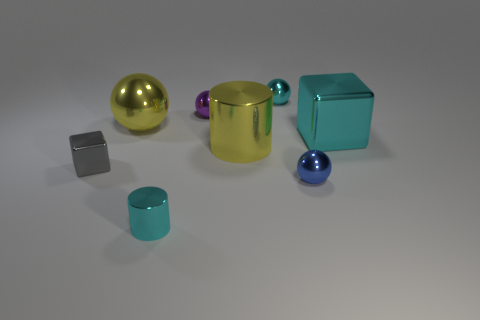Subtract all yellow spheres. How many spheres are left? 3 Add 2 big yellow metal cylinders. How many objects exist? 10 Subtract all cyan spheres. How many spheres are left? 3 Subtract all cubes. How many objects are left? 6 Subtract 3 balls. How many balls are left? 1 Subtract all brown balls. How many purple cubes are left? 0 Add 2 cyan balls. How many cyan balls are left? 3 Add 1 large cyan metal things. How many large cyan metal things exist? 2 Subtract 1 cyan cylinders. How many objects are left? 7 Subtract all yellow spheres. Subtract all gray cylinders. How many spheres are left? 3 